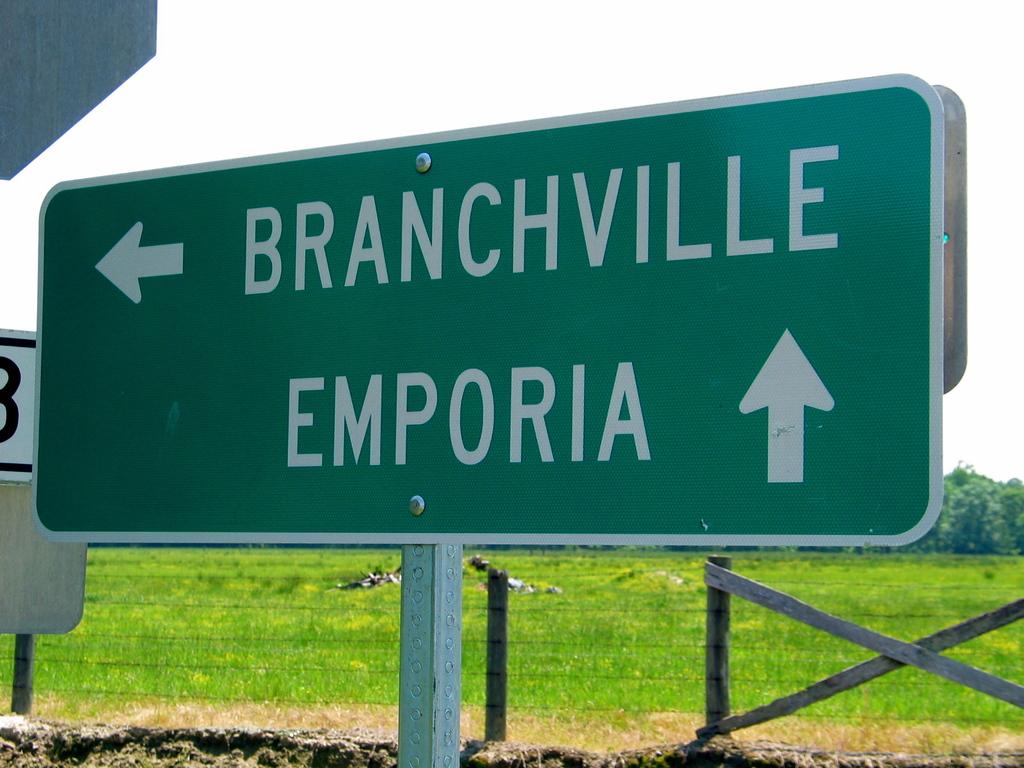Which town is straight ahead?
Provide a short and direct response. Emporia. What town is to the left?
Keep it short and to the point. Branchville. 